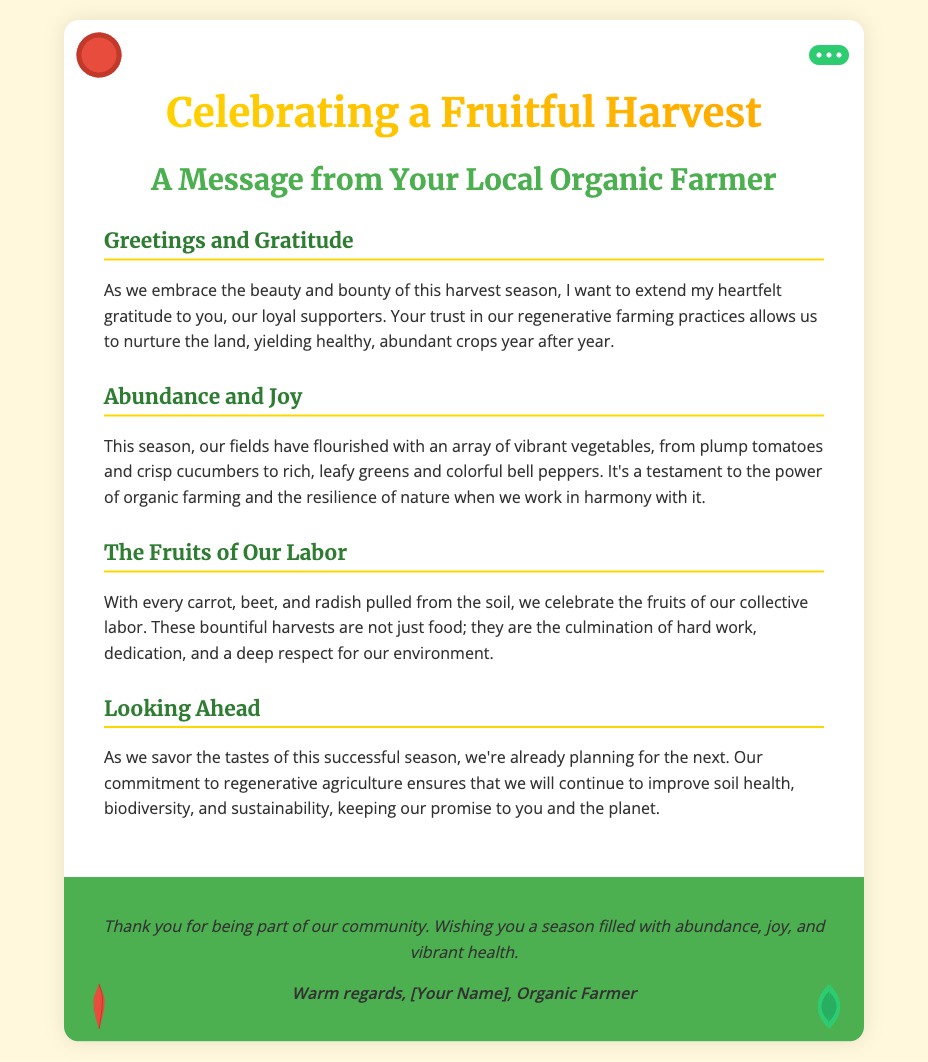What is the title of the card? The title of the card is prominently displayed at the top, indicating the celebration of the harvest season.
Answer: Celebrating a Fruitful Harvest Who is the card addressed to? The card includes a message indicating it is from a local organic farmer, showing appreciation to supporters.
Answer: Supporters What types of vegetables are mentioned in the card? The card lists several vegetables that represent the harvest, highlighting the bountiful yield.
Answer: Tomatoes, cucumbers, leafy greens, peppers What does the author express gratitude for? The author expresses gratitude for the support of loyal customers, acknowledging their role in the success of the farm.
Answer: Loyal supporters What is the main theme of the card? The main theme centers around celebrating the abundance of the harvest season and appreciating the support received.
Answer: Abundance and gratitude What does the author plan for the future? The author mentions a commitment to future planning in the context of maintaining sustainable farming practices.
Answer: Planning for the next season What is the decorative style of the card? The card features vibrant vegetable illustrations and subtle gold foil accents which emphasize abundance.
Answer: Vegetable illustrations and gold foil accents How does the author conclude the message? The conclusion of the message is a warm expression of thanks and well-wishing for the season ahead.
Answer: Wishing you a season filled with abundance, joy, and vibrant health 